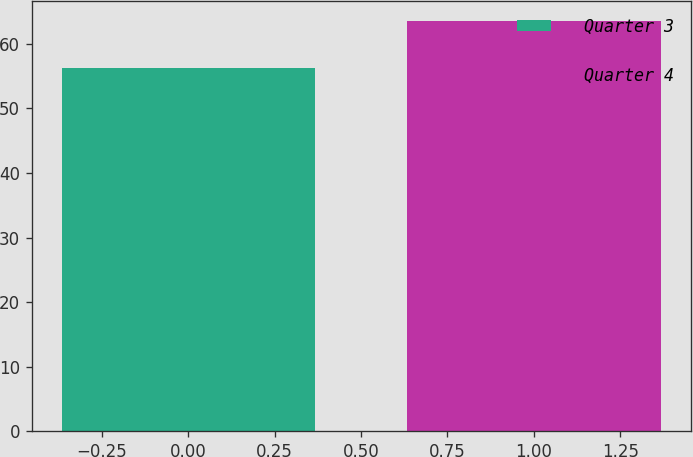Convert chart to OTSL. <chart><loc_0><loc_0><loc_500><loc_500><bar_chart><fcel>Quarter 3<fcel>Quarter 4<nl><fcel>56.22<fcel>63.44<nl></chart> 